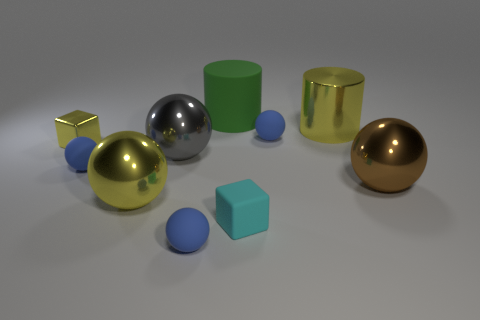Is the metal block the same color as the large shiny cylinder?
Your answer should be compact. Yes. How many things are either blue objects to the right of the rubber block or rubber balls?
Provide a short and direct response. 3. There is a big object behind the yellow shiny thing that is on the right side of the tiny blue object that is in front of the small cyan cube; what color is it?
Your answer should be very brief. Green. There is a small object that is made of the same material as the big yellow cylinder; what color is it?
Provide a succinct answer. Yellow. What number of blue things have the same material as the green cylinder?
Make the answer very short. 3. There is a brown metal sphere in front of the gray object; is its size the same as the small yellow thing?
Your answer should be compact. No. What color is the cylinder that is the same size as the green matte thing?
Give a very brief answer. Yellow. There is a green object; how many big yellow objects are to the left of it?
Keep it short and to the point. 1. Is there a large cyan shiny block?
Your response must be concise. No. There is a yellow metal thing that is right of the tiny sphere that is to the right of the tiny matte block in front of the large brown sphere; what is its size?
Your answer should be very brief. Large. 